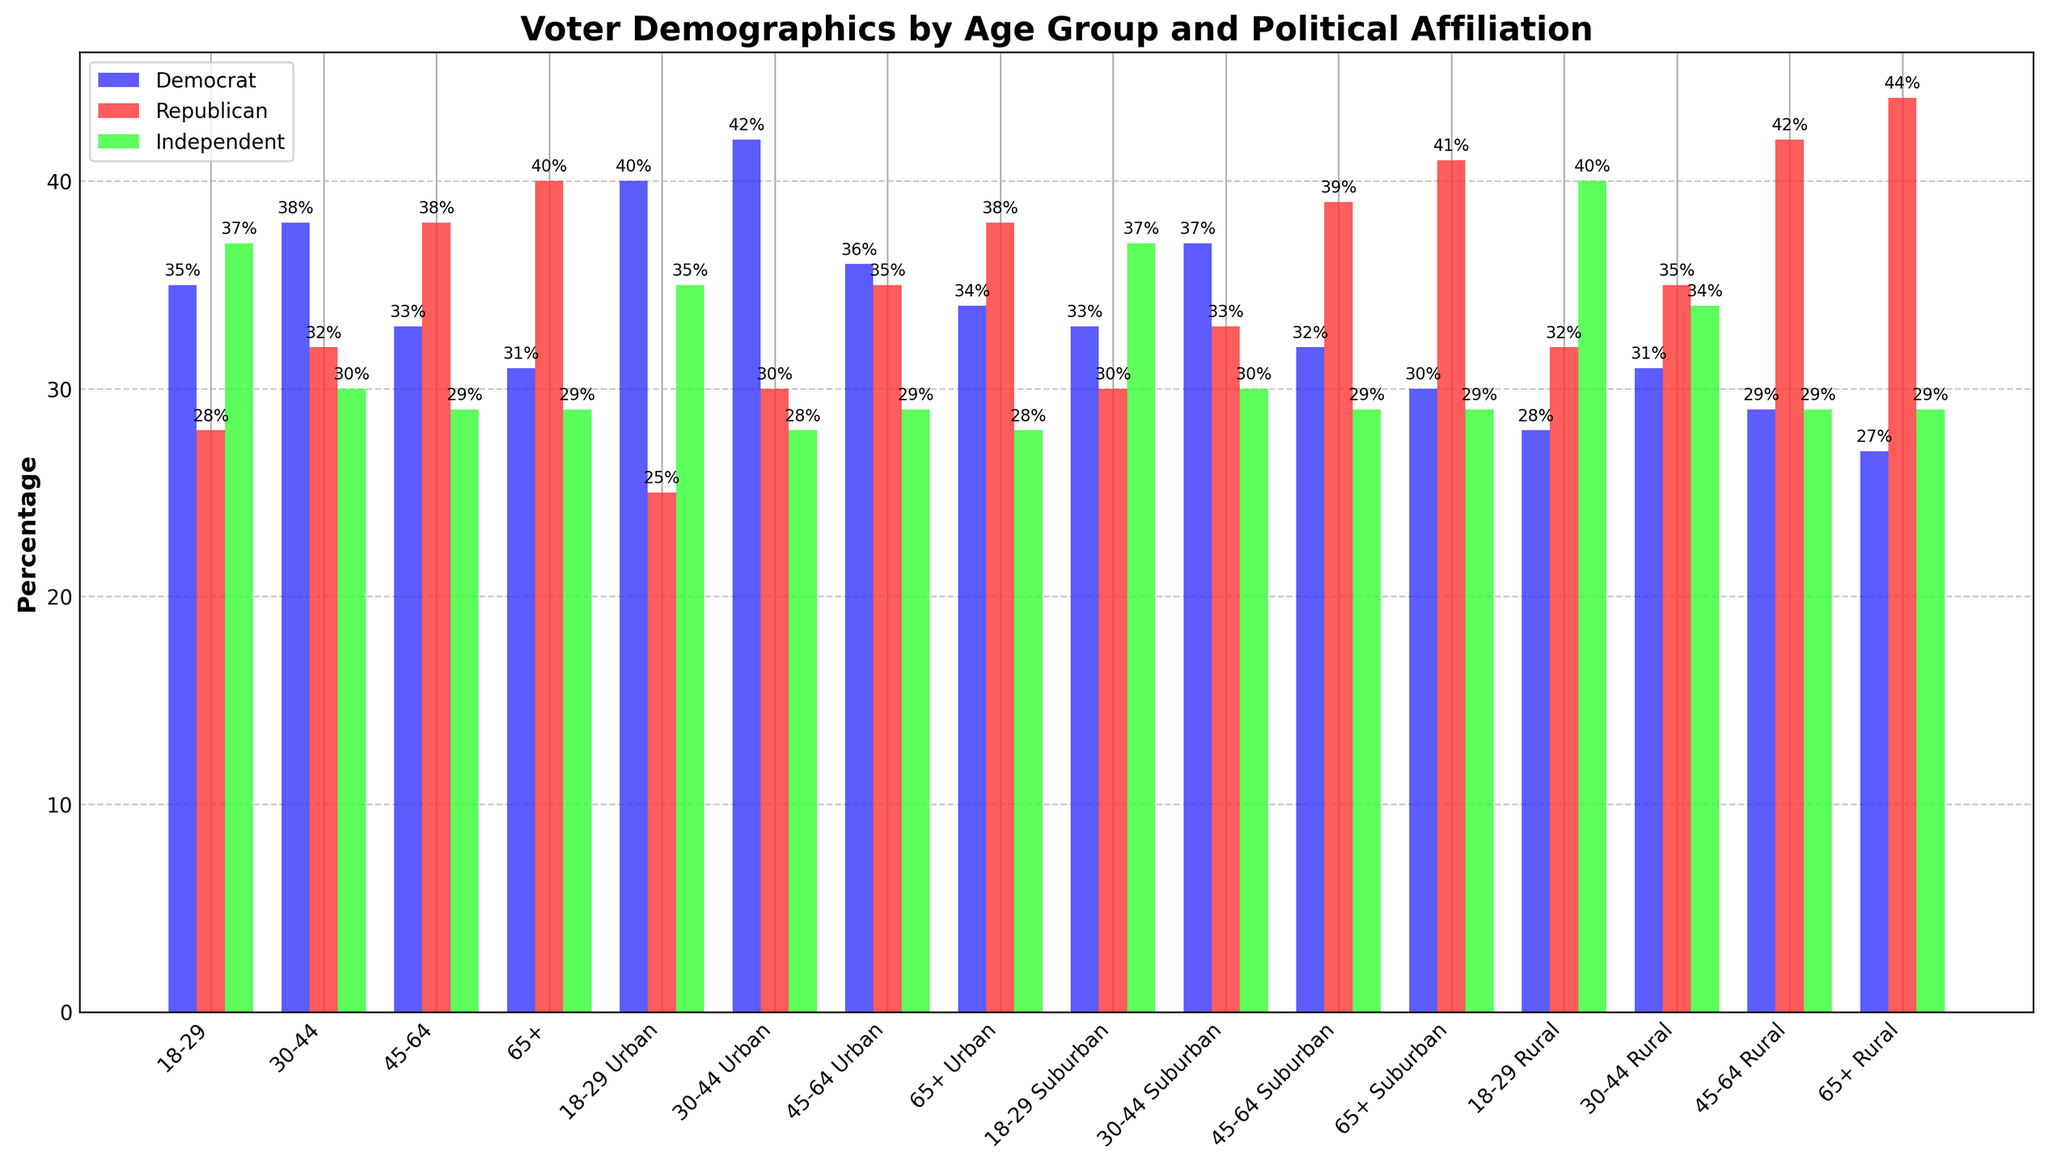What's the age group with the highest percentage of Democrats? From the figure, we identify the bars representing Democrats for each age group. The highest bar represents the age group 30-44.
Answer: 30-44 Which age group has the largest percentage difference between Republicans and Democrats? By examining each age group, we calculate the absolute differences in percentage between Republicans and Democrats. The age group 65+ has the largest difference: 40% (Republicans) - 31% (Democrats) = 9%.
Answer: 65+ In the 18-29 age group, does the percentage of Independents surpass that of Republicans? We compare the heights of the bars for Independents and Republicans within the 18-29 age group. The bar for Independents is taller (37%) than the bar for Republicans (28%).
Answer: Yes What is the combined percentage of Democrats and Independents in the 45-64 age group? We sum the percentages for Democrats (33%) and Independents (29%) in the 45-64 age group: 33% + 29% = 62%.
Answer: 62% Which political affiliation has the lowest average percentage across all age groups? We calculate the average percentage for each political affiliation. For Democrats: (35 + 38 + 33 + 31)/4 = 34.25%, Republicans: (28 + 32 + 38 + 40)/4 = 34.5%, Independents: (37 + 30 + 29 + 29)/4 = 31.25%. Independents have the lowest average.
Answer: Independents Comparing the 18-29 age group across Urban, Suburban, and Rural areas, which subgroup has the highest percentage of Independents? From the data, the Urban 18-29 group (35%) has the highest percentage of Independents compared to Suburban (37%) and Rural (40%). Thus, Rural 18-29 has the highest.
Answer: Rural 18-29 Which age group shows a majority for any political affiliation in Rural areas? We look at the Rural data where a percentage exceeds 50%. The Rural 65+ age group has the highest percentage for Republicans at 44%, but it doesn't surpass 50%, so no majority.
Answer: None Is there any age group where the percentage of Democrats is consistently lower in Rural areas compared to Urban areas? Comparing respective age groups, 18-29: Urban 40%, Rural 28%. 30-44: Urban 42%, Rural 31%. 45-64: Urban 36%, Rural 29%. 65+: Urban 34%, Rural 27%. All rural percentages are lower.
Answer: Yes In the 30-44 age group, how much higher is the Democrat percentage in Urban areas compared to Rural areas? For the 30-44 age group, we subtract the Rural percentage (31%) from the Urban percentage (42%): 42% - 31% = 11%.
Answer: 11% For the 65+ age group, is the difference in percentages between Republicans and Democrats greater in Suburban areas compared to Rural areas? Calculate the differences: Suburban: 41% - 30% = 11%, Rural: 44% - 27% = 17%. The Rural difference (17%) is greater than the Suburban difference (11%).
Answer: No 